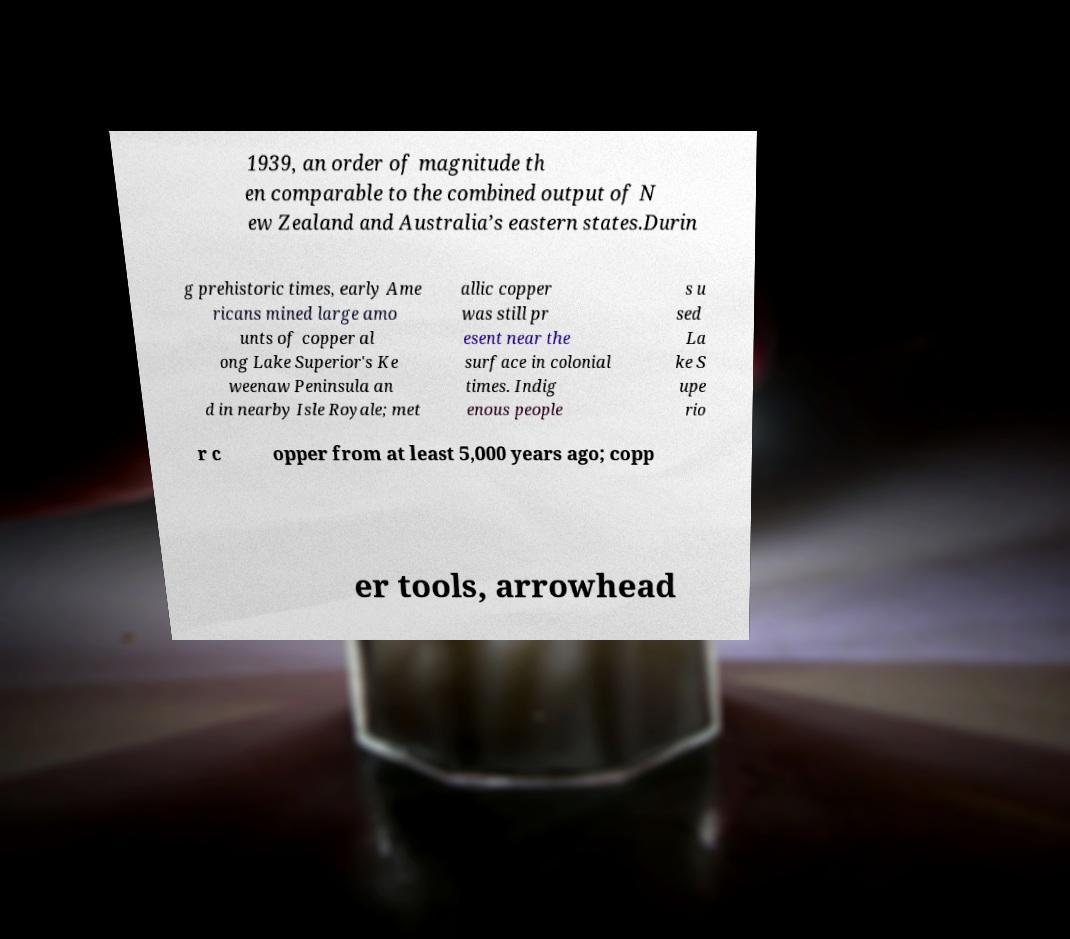What messages or text are displayed in this image? I need them in a readable, typed format. 1939, an order of magnitude th en comparable to the combined output of N ew Zealand and Australia’s eastern states.Durin g prehistoric times, early Ame ricans mined large amo unts of copper al ong Lake Superior's Ke weenaw Peninsula an d in nearby Isle Royale; met allic copper was still pr esent near the surface in colonial times. Indig enous people s u sed La ke S upe rio r c opper from at least 5,000 years ago; copp er tools, arrowhead 